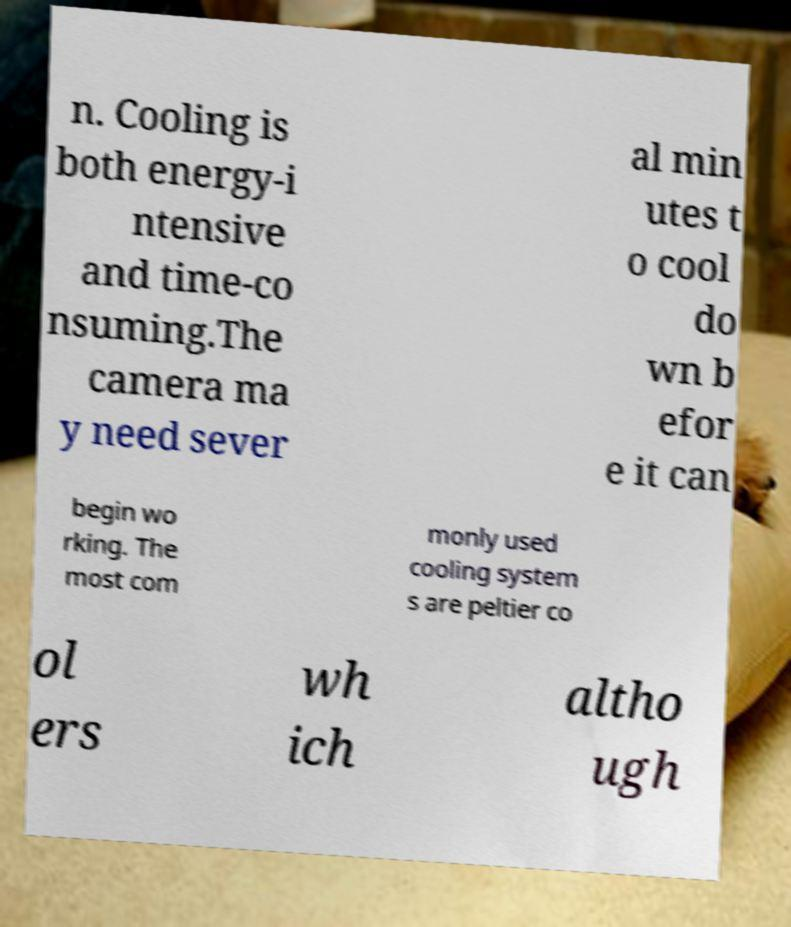Please identify and transcribe the text found in this image. n. Cooling is both energy-i ntensive and time-co nsuming.The camera ma y need sever al min utes t o cool do wn b efor e it can begin wo rking. The most com monly used cooling system s are peltier co ol ers wh ich altho ugh 